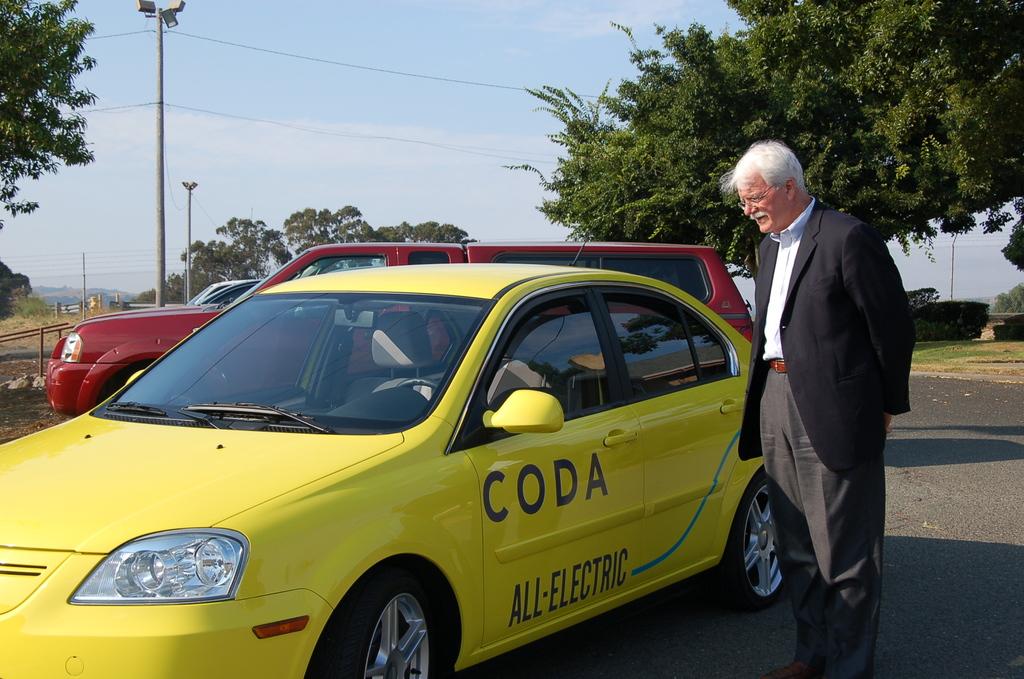What word is listed on the top part of the door?
Offer a terse response. Coda. What kind of car is this?
Make the answer very short. All-electric. 